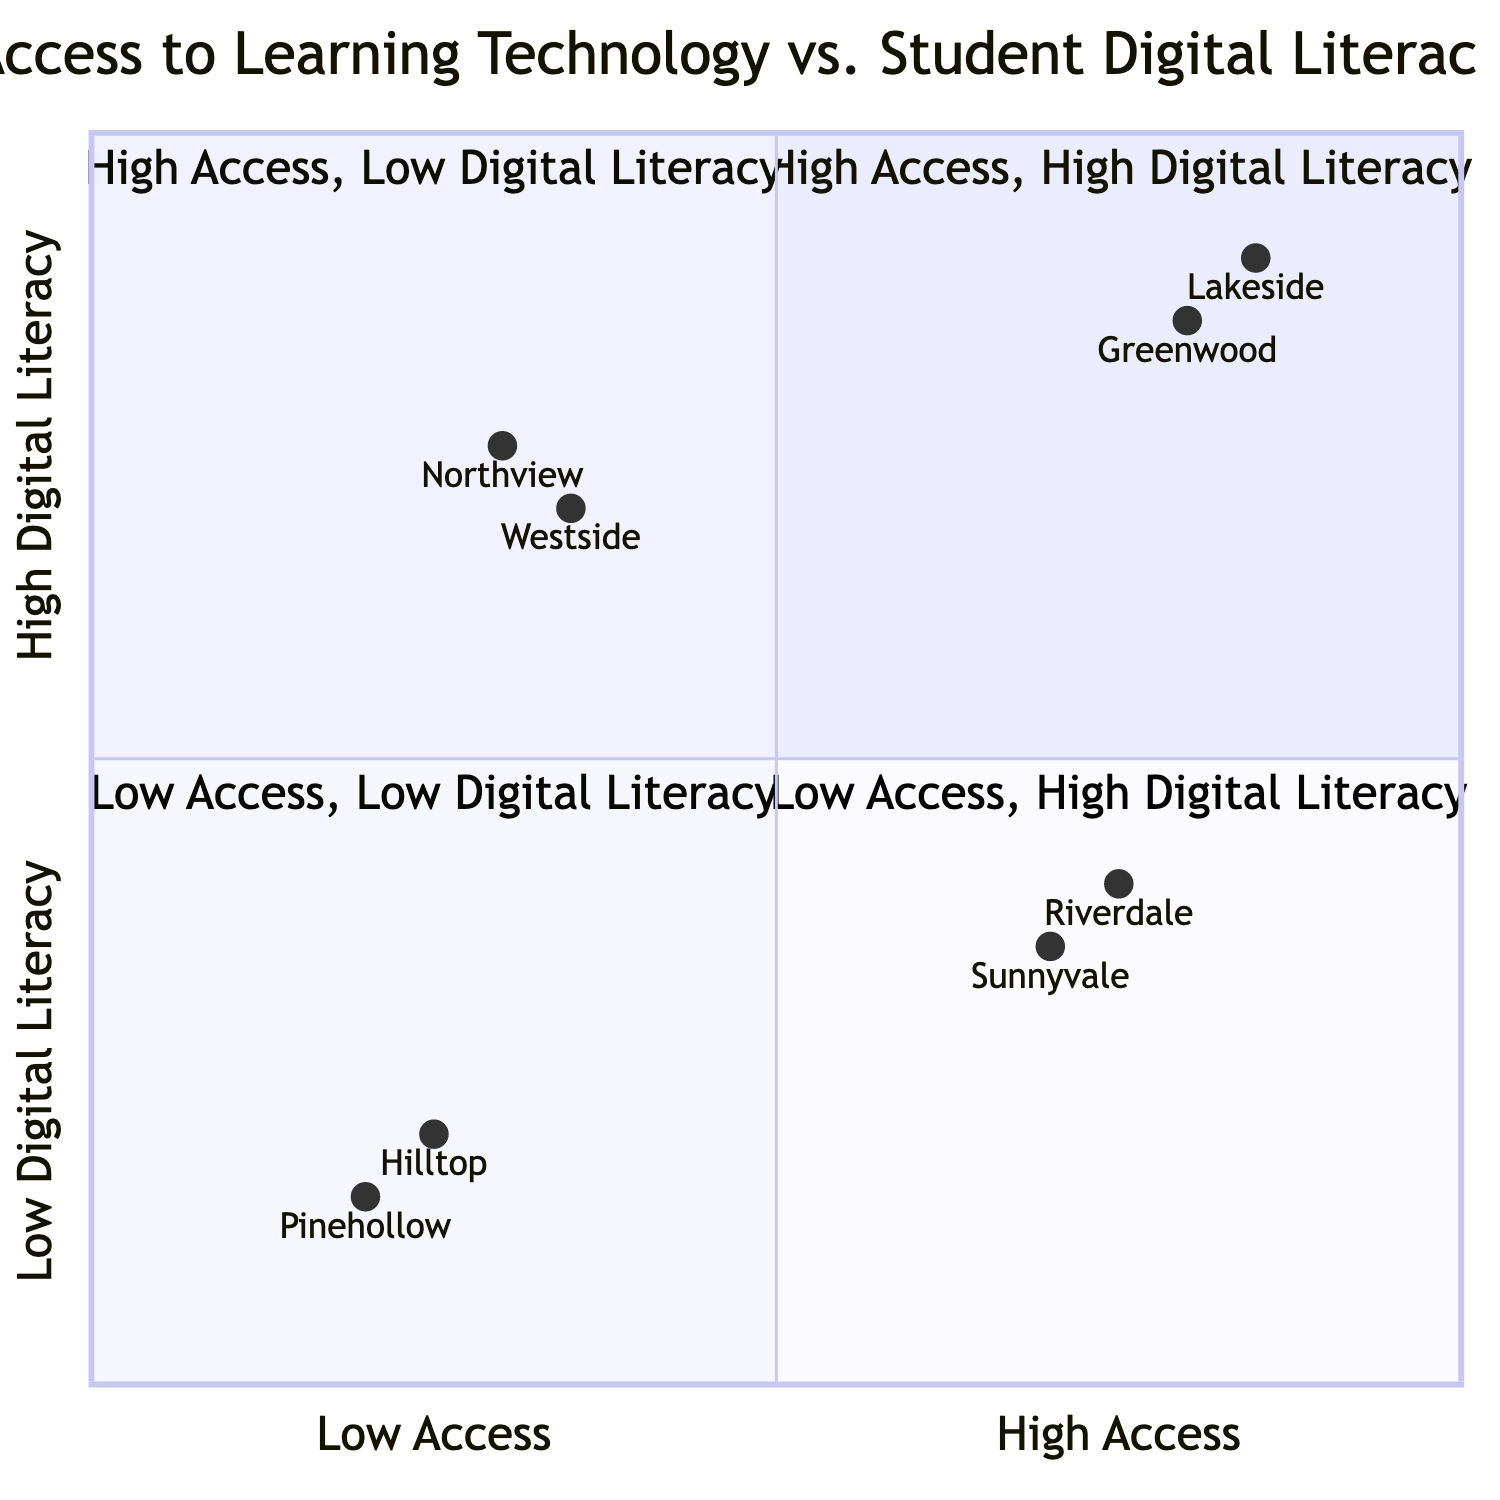What schools fall into the High Access, High Digital Literacy quadrant? The High Access, High Digital Literacy quadrant (Q1) contains Lakeside High School and Greenwood Elementary.
Answer: Lakeside High School, Greenwood Elementary Which quadrant has the most schools listed? Each quadrant has two schools listed, so there are no quadrants with more schools than others.
Answer: No quadrant has more schools What funding source does Riverdale Middle School receive? The funding source for Riverdale Middle School is Federal STEM Grants, as stated in the data provided for that school's representation in the diagram.
Answer: Federal STEM Grants How many schools are in the Low Access, Low Digital Literacy quadrant? The Low Access, Low Digital Literacy quadrant (Q3) features two schools, Pinehollow Elementary and Hilltop Middle School.
Answer: Two schools Which school has the highest digital literacy based on the diagram? Lakeside High School has the highest digital literacy value of 0.9, based on the coordinates provided for the schools in the diagram.
Answer: Lakeside High School What performance outcome is associated with Sunnyvale High School? Sunnyvale High School has varying digital skill levels and cybersecurity issues as its performance outcomes according to the quadrant chart data.
Answer: Varying digital skill levels, Cybersecurity issues Which quadrant includes schools with shared devices among classrooms? The Low Access, Low Digital Literacy quadrant (Q3) includes Hilltop Middle School, which has shared devices among classrooms, as part of its programs.
Answer: Low Access, Low Digital Literacy What is the performance outcome for Westside Elementary? Westside Elementary has strong problem-solving skills and an active learning community as its performance outcomes, according to the information in the quadrant.
Answer: Strong problem-solving skills, Active learning community 